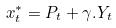Convert formula to latex. <formula><loc_0><loc_0><loc_500><loc_500>x _ { t } ^ { * } = P _ { t } + \gamma . Y _ { t }</formula> 